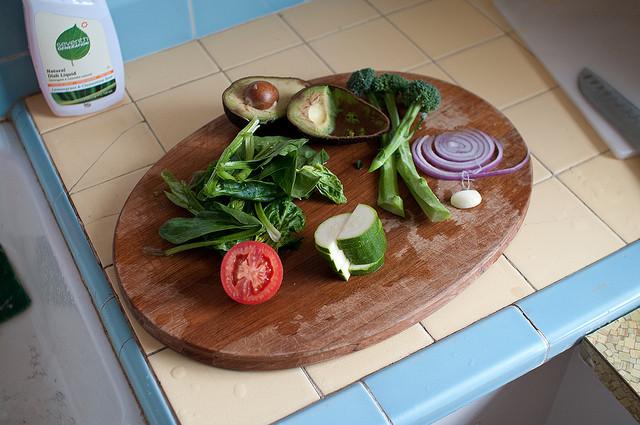Is there any meat on the counter?
Quick response, please. No. Has the tomato on the counter been sliced?
Concise answer only. Yes. Are there fruits on the platter?
Give a very brief answer. No. 